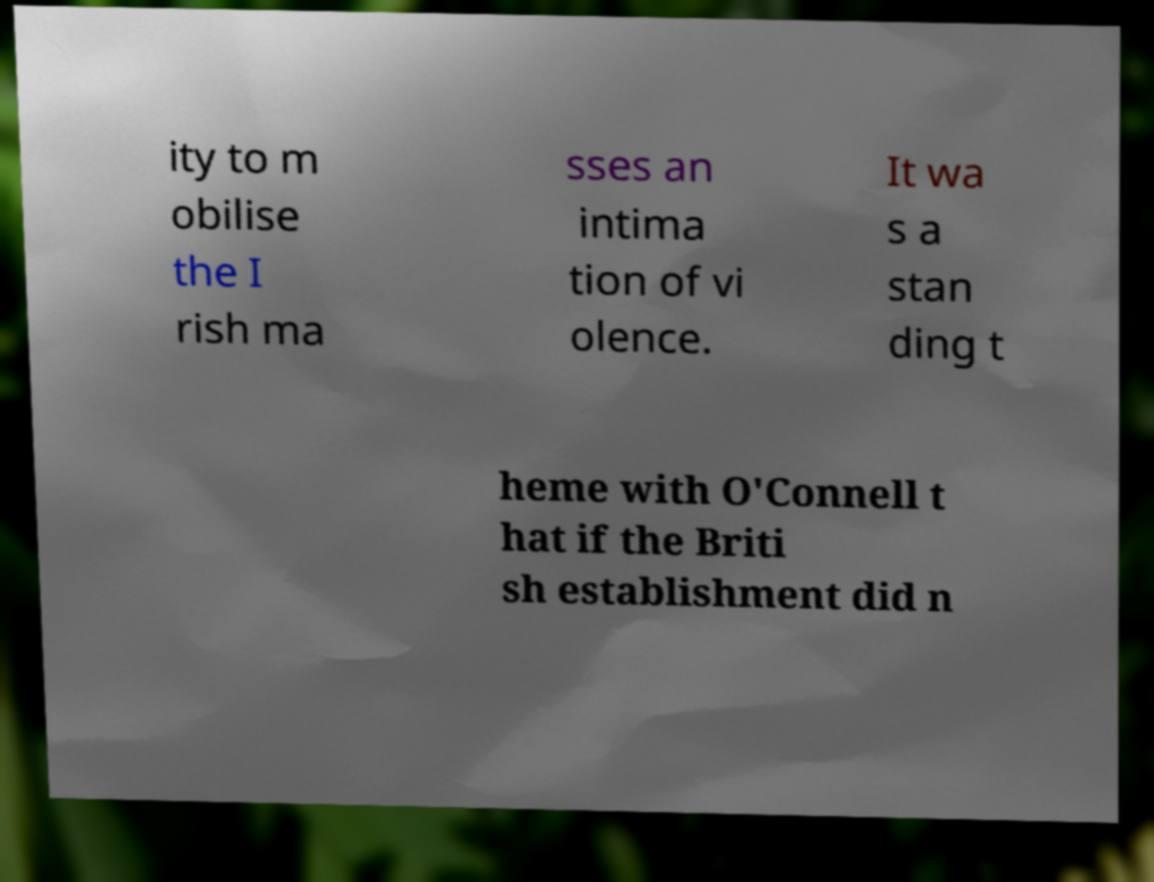Could you assist in decoding the text presented in this image and type it out clearly? ity to m obilise the I rish ma sses an intima tion of vi olence. It wa s a stan ding t heme with O'Connell t hat if the Briti sh establishment did n 